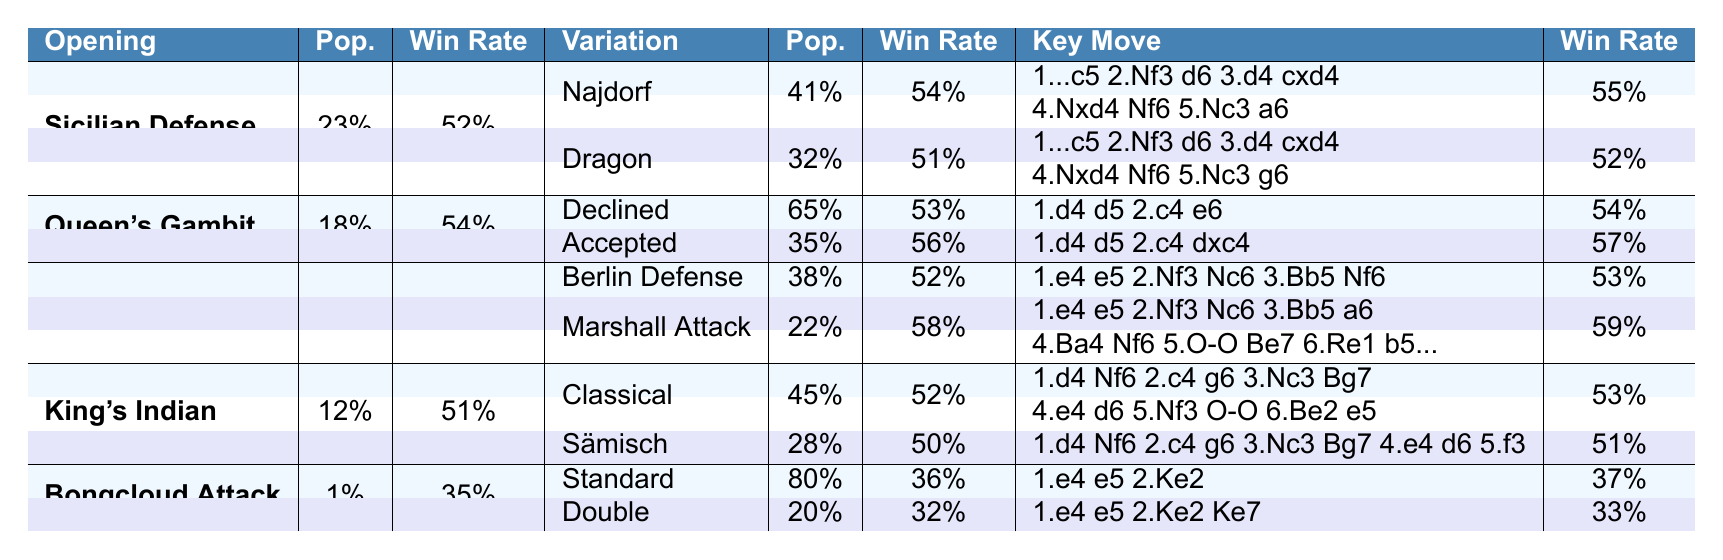What is the win rate for the Najdorf Variation of the Sicilian Defense? The table shows that the win rate for the Najdorf Variation is listed under the "Win Rate" column for that specific variation, which is 54%.
Answer: 54% Which opening has the highest win rate according to the table? The table lists the win rates for each opening; the Marshall Attack variation of the Ruy Lopez has the highest win rate of 59%.
Answer: 59% How popular is the Queen's Gambit compared to the King's Indian Defense? The Queen's Gambit has a popularity of 18%, while the King's Indian Defense has a popularity of 12%. Comparing these values, Queen's Gambit is more popular than King's Indian Defense.
Answer: Yes, it is more popular What is the average win rate of the variations listed under the King's Indian Defense? The variations are Classical (52%) and Sämisch (50%). Adding these gives 102%, and dividing by 2 provides the average win rate of 51%.
Answer: 51% Which opening has the lowest popularity and win rate, and what are those values? The Bongcloud Attack has the lowest popularity at 1% and a win rate of 35% according to the values provided in the table.
Answer: 1% popularity and 35% win rate Is the win rate for the Bongcloud's Standard variation higher than that of the King's Indian Defense's Classical variation? The win rate for the Standard Bongcloud variation is 36%, while the Classical variation of the King's Indian Defense has a win rate of 52%. Since 36% is less than 52%, the Bongcloud is not higher.
Answer: No What is the difference in popularity between the highest and lowest variation? The most popular variation is the Declined variation of Queen's Gambit at 65%, while the least popular is the Bongcloud Attack at 1%. The difference is calculated as 65% - 1% = 64%.
Answer: 64% Which variation has a win rate closest to the average win rate of the Sicilian Defense? The Sicilian Defense has an overall win rate of 52%. The Najdorf Variation (54%) is closest, followed by the Dragon Variation (51%). The closest based on a one-step difference is Najdorf.
Answer: Najdorf Variation 